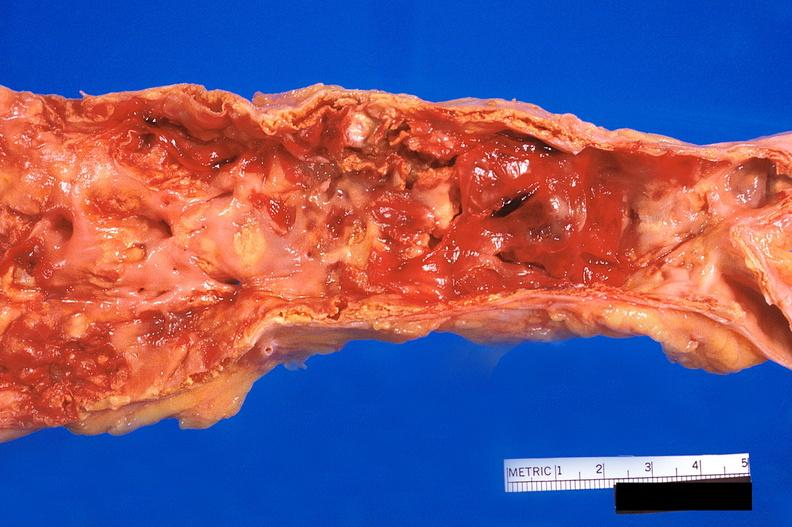s cardiovascular present?
Answer the question using a single word or phrase. Yes 